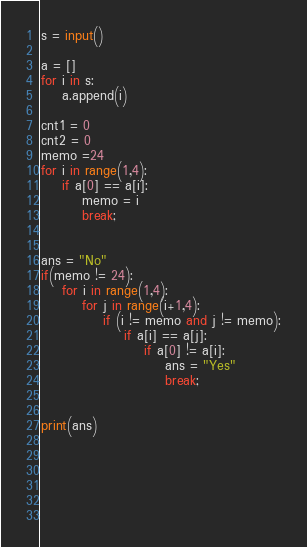Convert code to text. <code><loc_0><loc_0><loc_500><loc_500><_Python_>s = input()

a = []
for i in s:
    a.append(i)

cnt1 = 0
cnt2 = 0
memo =24
for i in range(1,4):
    if a[0] == a[i]:
        memo = i
        break;
    

ans = "No"
if(memo != 24):
    for i in range(1,4):
        for j in range(i+1,4):
            if (i != memo and j != memo):
                if a[i] == a[j]:
                    if a[0] != a[i]:
                        ans = "Yes"
                        break;


print(ans)
                        
            
    
    
    
    
</code> 